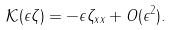Convert formula to latex. <formula><loc_0><loc_0><loc_500><loc_500>\mathcal { K } ( \epsilon \zeta ) = - \epsilon \zeta _ { x x } + O ( \epsilon ^ { 2 } ) .</formula> 